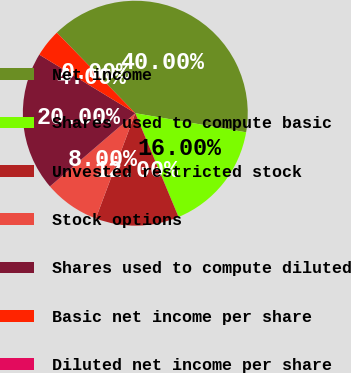Convert chart to OTSL. <chart><loc_0><loc_0><loc_500><loc_500><pie_chart><fcel>Net income<fcel>Shares used to compute basic<fcel>Unvested restricted stock<fcel>Stock options<fcel>Shares used to compute diluted<fcel>Basic net income per share<fcel>Diluted net income per share<nl><fcel>40.0%<fcel>16.0%<fcel>12.0%<fcel>8.0%<fcel>20.0%<fcel>4.0%<fcel>0.0%<nl></chart> 